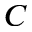Convert formula to latex. <formula><loc_0><loc_0><loc_500><loc_500>C</formula> 